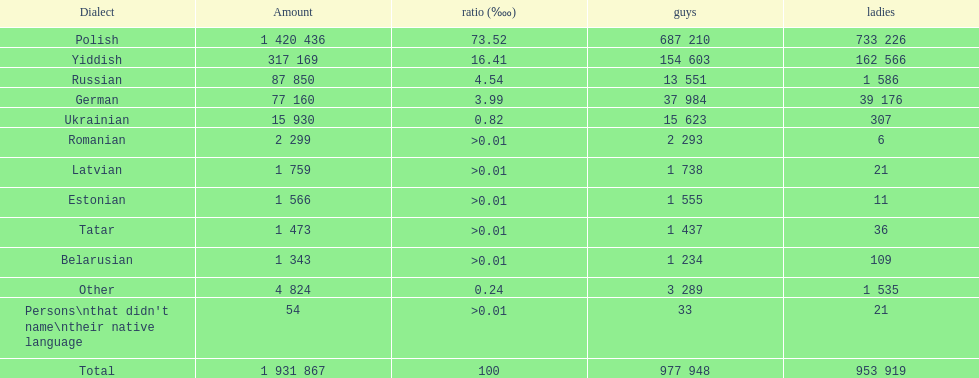What was the top language from the one's whose percentage was >0.01 Romanian. 